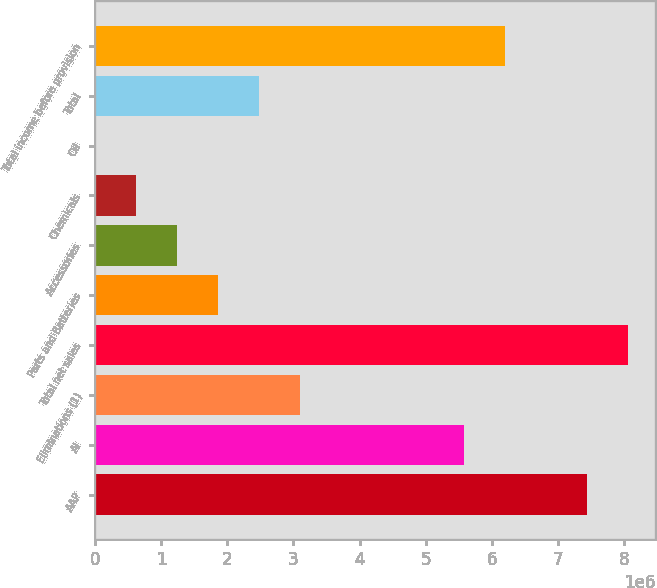<chart> <loc_0><loc_0><loc_500><loc_500><bar_chart><fcel>AAP<fcel>AI<fcel>Eliminations (1)<fcel>Total net sales<fcel>Parts and Batteries<fcel>Accessories<fcel>Chemicals<fcel>Oil<fcel>Total<fcel>Total income before provision<nl><fcel>7.446e+06<fcel>5.5845e+06<fcel>3.10251e+06<fcel>8.0665e+06<fcel>1.86151e+06<fcel>1.24101e+06<fcel>620509<fcel>10<fcel>2.48201e+06<fcel>6.205e+06<nl></chart> 